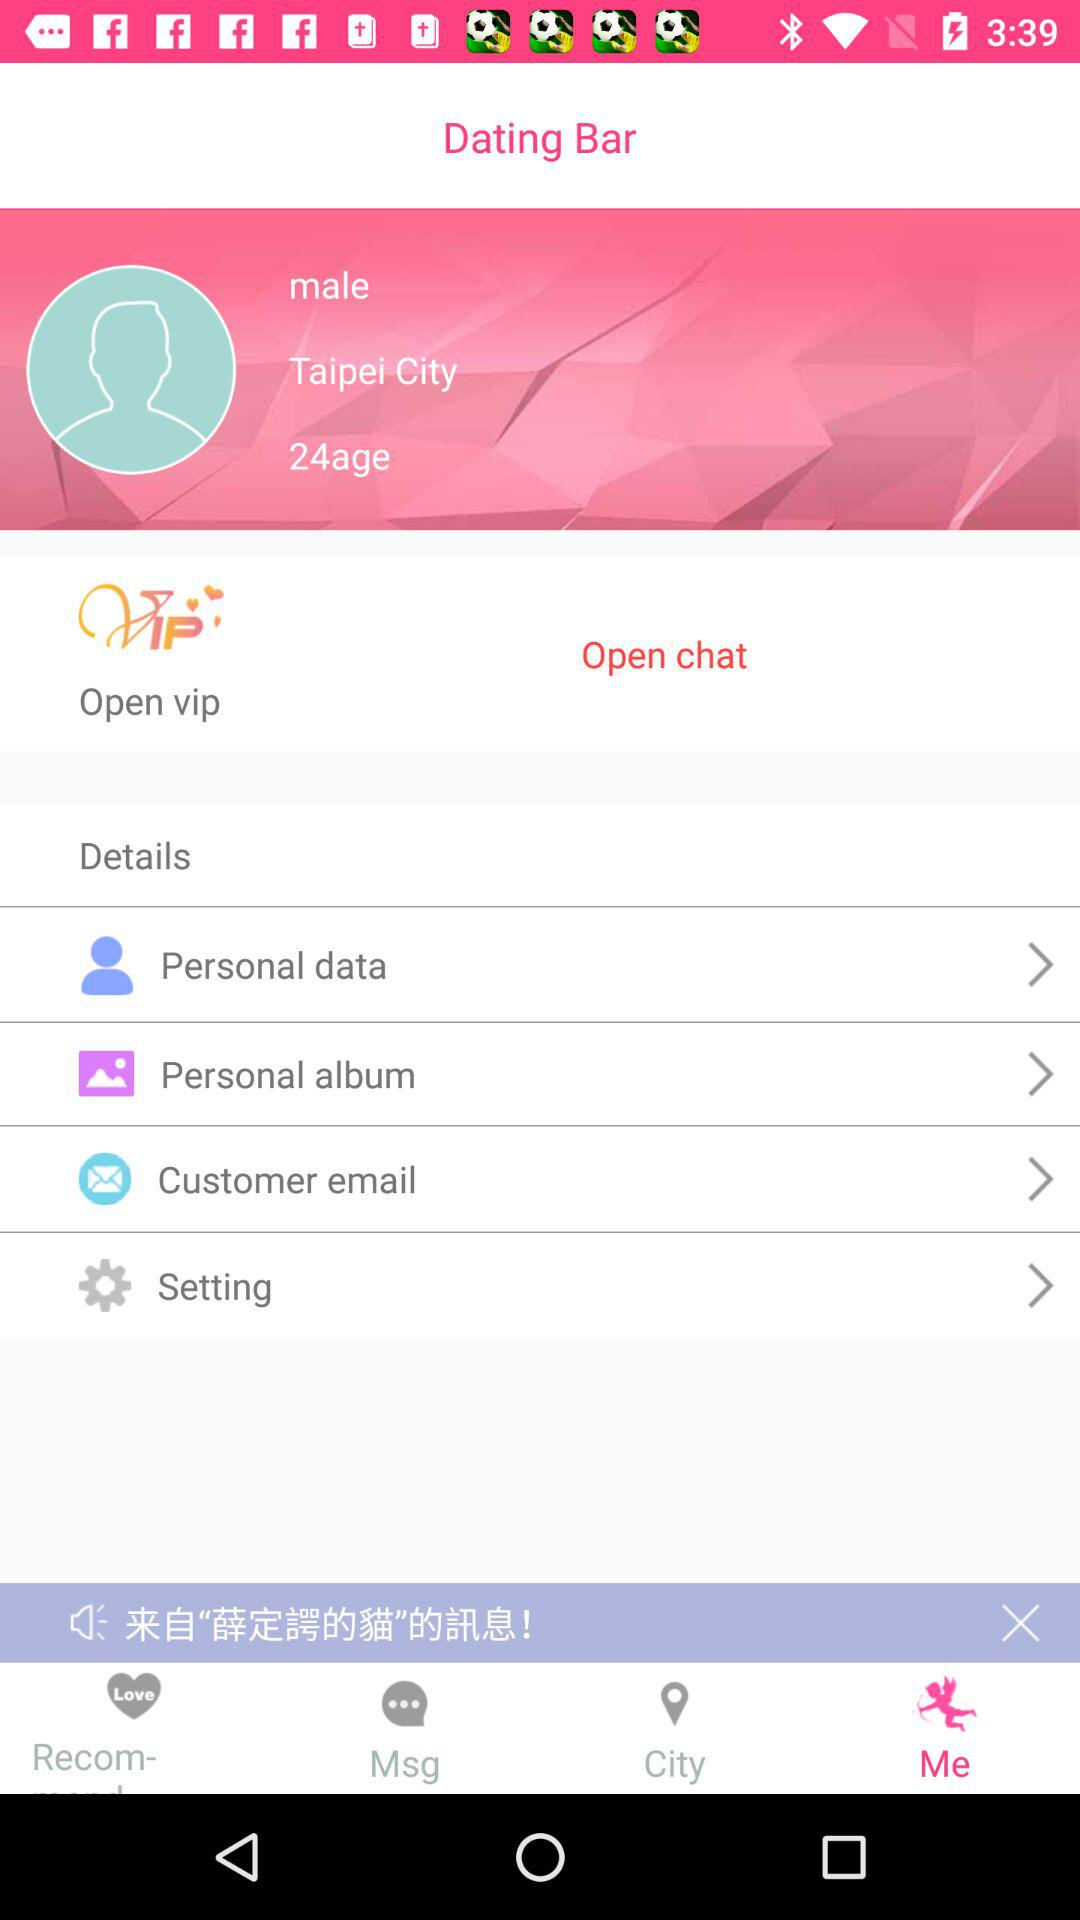What is the location of the user? The location of the user is Taipei City. 